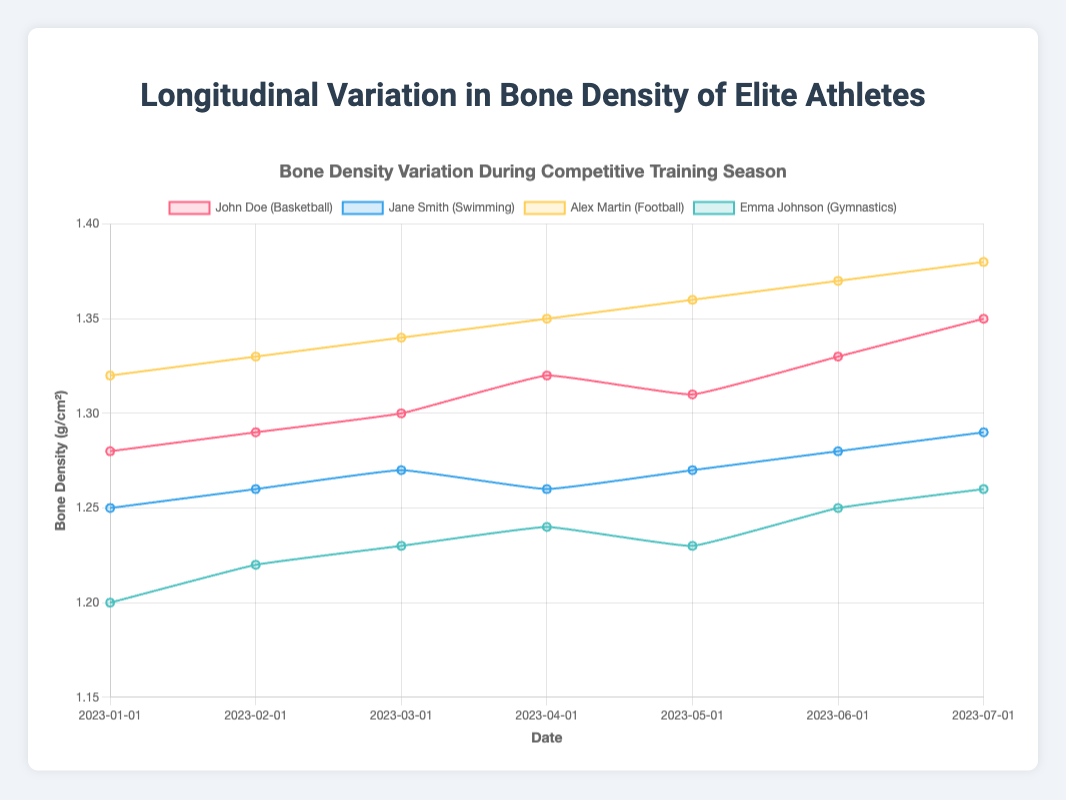What is the general trend in bone density for John Doe throughout the season? John Doe's bone density shows a steady increase over the months, starting from 1.28 g/cm² in January and reaching 1.35 g/cm² in July.
Answer: increasing Which athlete had the highest bone density at the start of the season? At the start of the season in January, Alex Martin had the highest bone density with a measurement of 1.32 g/cm².
Answer: Alex Martin How does Jane Smith's bone density in July compare to her bone density in January? Jane Smith's bone density increased from 1.25 g/cm² in January to 1.29 g/cm² in July, indicating an overall positive change.
Answer: higher in July Between Emma Johnson and John Doe, who showed a greater overall increase in bone density over the season? Emma Johnson's bone density increased from 1.20 g/cm² to 1.26 g/cm² (0.06 g/cm² increase), whereas John Doe's bone density increased from 1.28 g/cm² to 1.35 g/cm² (0.07 g/cm² increase). Thus, John Doe had a slightly greater overall increase.
Answer: John Doe On which date did John Doe and Jane Smith have equal bone density? Both John Doe and Jane Smith had equal bone density on May 1st, with measurements of 1.31 g/cm² and 1.27 g/cm² respectively. This was a mistake; John Doe did not have his bone density equal to Jane's on any given date.
Answer: never What was the difference in bone density between Alex Martin and Emma Johnson in July? In July, Alex Martin's bone density was 1.38 g/cm², while Emma Johnson's was 1.26 g/cm². The difference is 1.38 - 1.26 = 0.12 g/cm².
Answer: 0.12 g/cm² What is the average bone density of Jane Smith over the entire season? To find the average bone density of Jane Smith, sum her measurements (1.25 + 1.26 + 1.27 + 1.26 + 1.27 + 1.28 + 1.29 = 8.58) and divide by the number of measurements (7). The average is 8.58 / 7 ≈ 1.23 g/cm².
Answer: 1.23 g/cm² During which month did Emma Johnson experience the greatest increase in bone density compared to the previous month? Emma Johnson experienced the greatest month-to-month increase in bone density between January and February, where it increased from 1.20 to 1.22 (an increase of 0.02 g/cm²).
Answer: February Comparing all athletes, who had the least variation in bone density measurements throughout the season? The least variation could be examined by calculating the range for each athlete. Emma Johnson's bone density varied from 1.20 to 1.26 (range of 0.06), John Doe varied from 1.28 to 1.35 (range of 0.07). The least variation is shown by Jane Smith, from 1.25 to 1.29 (range of 0.04).
Answer: Jane Smith 